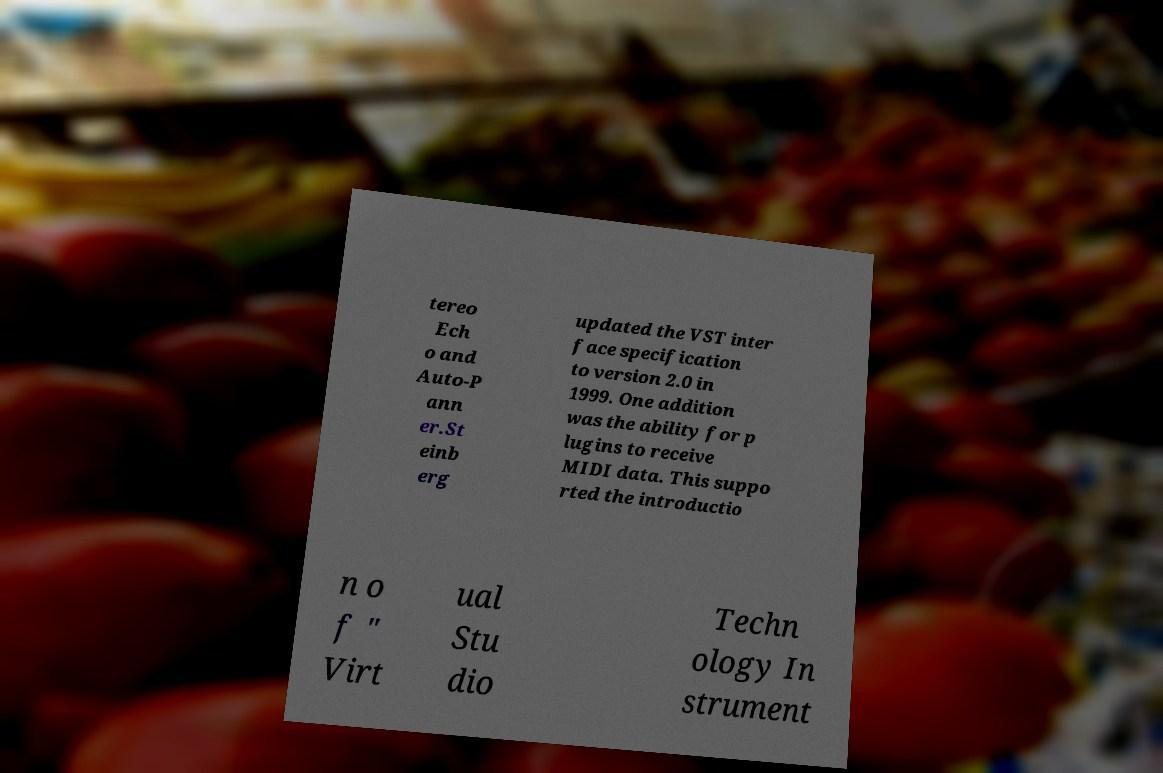Could you assist in decoding the text presented in this image and type it out clearly? tereo Ech o and Auto-P ann er.St einb erg updated the VST inter face specification to version 2.0 in 1999. One addition was the ability for p lugins to receive MIDI data. This suppo rted the introductio n o f " Virt ual Stu dio Techn ology In strument 